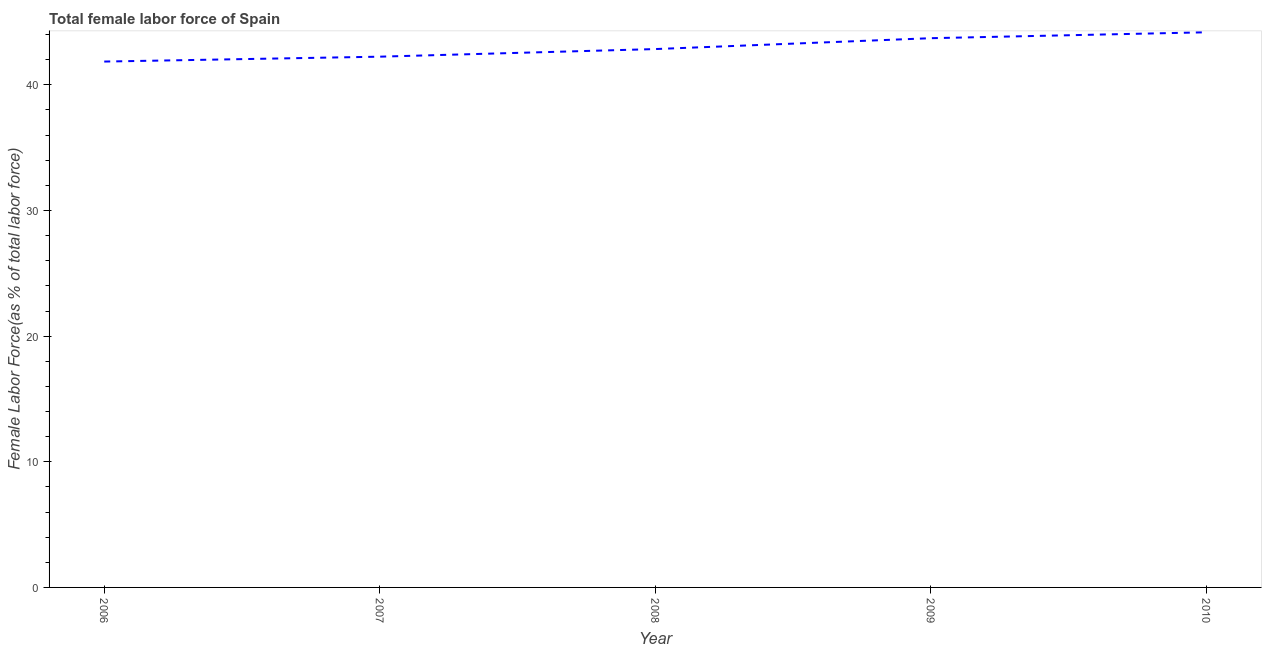What is the total female labor force in 2010?
Offer a terse response. 44.18. Across all years, what is the maximum total female labor force?
Make the answer very short. 44.18. Across all years, what is the minimum total female labor force?
Give a very brief answer. 41.85. In which year was the total female labor force maximum?
Your response must be concise. 2010. In which year was the total female labor force minimum?
Your response must be concise. 2006. What is the sum of the total female labor force?
Offer a terse response. 214.84. What is the difference between the total female labor force in 2006 and 2009?
Keep it short and to the point. -1.86. What is the average total female labor force per year?
Your response must be concise. 42.97. What is the median total female labor force?
Your answer should be compact. 42.85. In how many years, is the total female labor force greater than 16 %?
Ensure brevity in your answer.  5. Do a majority of the years between 2010 and 2006 (inclusive) have total female labor force greater than 4 %?
Offer a very short reply. Yes. What is the ratio of the total female labor force in 2008 to that in 2010?
Your answer should be compact. 0.97. Is the difference between the total female labor force in 2006 and 2008 greater than the difference between any two years?
Offer a very short reply. No. What is the difference between the highest and the second highest total female labor force?
Your answer should be compact. 0.47. What is the difference between the highest and the lowest total female labor force?
Your answer should be very brief. 2.33. In how many years, is the total female labor force greater than the average total female labor force taken over all years?
Your answer should be very brief. 2. Does the total female labor force monotonically increase over the years?
Provide a succinct answer. Yes. How many years are there in the graph?
Offer a terse response. 5. Are the values on the major ticks of Y-axis written in scientific E-notation?
Keep it short and to the point. No. Does the graph contain any zero values?
Make the answer very short. No. Does the graph contain grids?
Make the answer very short. No. What is the title of the graph?
Your answer should be compact. Total female labor force of Spain. What is the label or title of the X-axis?
Provide a succinct answer. Year. What is the label or title of the Y-axis?
Your response must be concise. Female Labor Force(as % of total labor force). What is the Female Labor Force(as % of total labor force) of 2006?
Give a very brief answer. 41.85. What is the Female Labor Force(as % of total labor force) of 2007?
Ensure brevity in your answer.  42.24. What is the Female Labor Force(as % of total labor force) in 2008?
Your answer should be very brief. 42.85. What is the Female Labor Force(as % of total labor force) of 2009?
Make the answer very short. 43.71. What is the Female Labor Force(as % of total labor force) in 2010?
Keep it short and to the point. 44.18. What is the difference between the Female Labor Force(as % of total labor force) in 2006 and 2007?
Offer a very short reply. -0.39. What is the difference between the Female Labor Force(as % of total labor force) in 2006 and 2008?
Ensure brevity in your answer.  -0.99. What is the difference between the Female Labor Force(as % of total labor force) in 2006 and 2009?
Make the answer very short. -1.86. What is the difference between the Female Labor Force(as % of total labor force) in 2006 and 2010?
Keep it short and to the point. -2.33. What is the difference between the Female Labor Force(as % of total labor force) in 2007 and 2008?
Ensure brevity in your answer.  -0.61. What is the difference between the Female Labor Force(as % of total labor force) in 2007 and 2009?
Give a very brief answer. -1.47. What is the difference between the Female Labor Force(as % of total labor force) in 2007 and 2010?
Offer a very short reply. -1.94. What is the difference between the Female Labor Force(as % of total labor force) in 2008 and 2009?
Your answer should be very brief. -0.87. What is the difference between the Female Labor Force(as % of total labor force) in 2008 and 2010?
Provide a succinct answer. -1.34. What is the difference between the Female Labor Force(as % of total labor force) in 2009 and 2010?
Make the answer very short. -0.47. What is the ratio of the Female Labor Force(as % of total labor force) in 2006 to that in 2007?
Ensure brevity in your answer.  0.99. What is the ratio of the Female Labor Force(as % of total labor force) in 2006 to that in 2008?
Offer a very short reply. 0.98. What is the ratio of the Female Labor Force(as % of total labor force) in 2006 to that in 2009?
Keep it short and to the point. 0.96. What is the ratio of the Female Labor Force(as % of total labor force) in 2006 to that in 2010?
Ensure brevity in your answer.  0.95. What is the ratio of the Female Labor Force(as % of total labor force) in 2007 to that in 2009?
Offer a terse response. 0.97. What is the ratio of the Female Labor Force(as % of total labor force) in 2007 to that in 2010?
Offer a very short reply. 0.96. 